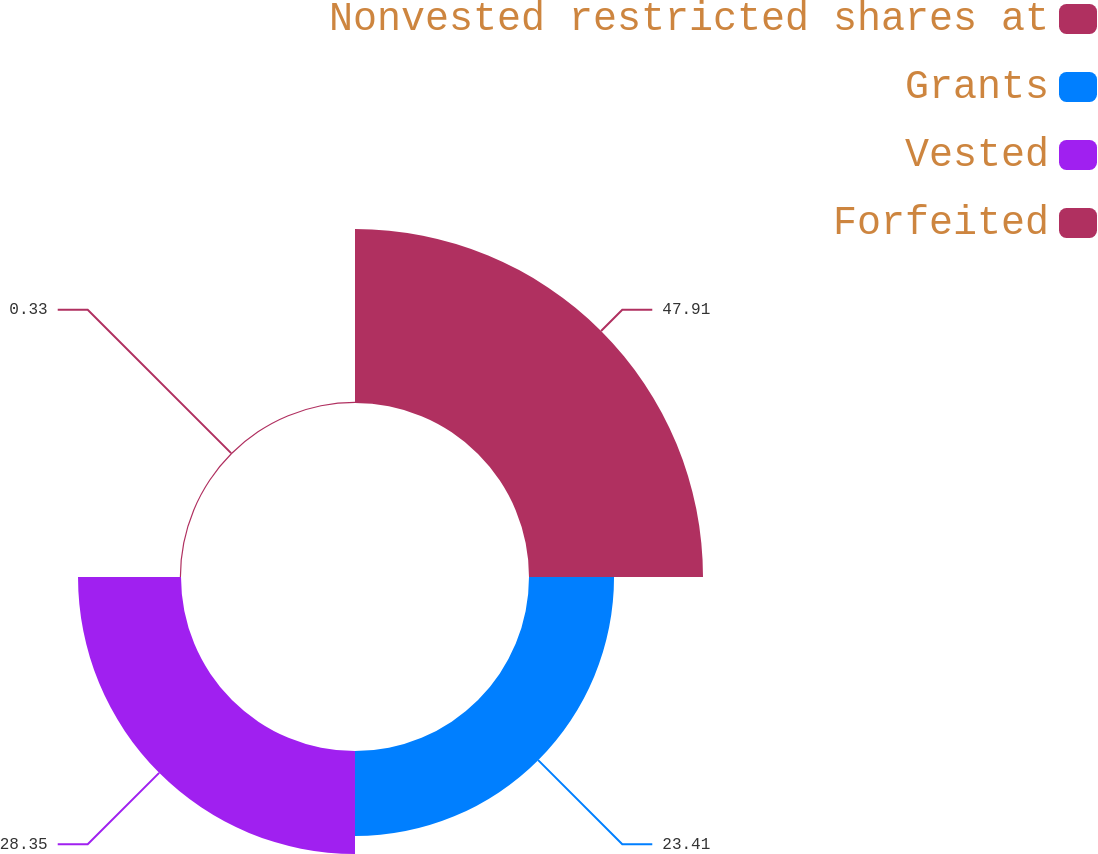<chart> <loc_0><loc_0><loc_500><loc_500><pie_chart><fcel>Nonvested restricted shares at<fcel>Grants<fcel>Vested<fcel>Forfeited<nl><fcel>47.9%<fcel>23.41%<fcel>28.35%<fcel>0.33%<nl></chart> 